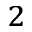Convert formula to latex. <formula><loc_0><loc_0><loc_500><loc_500>_ { 2 }</formula> 